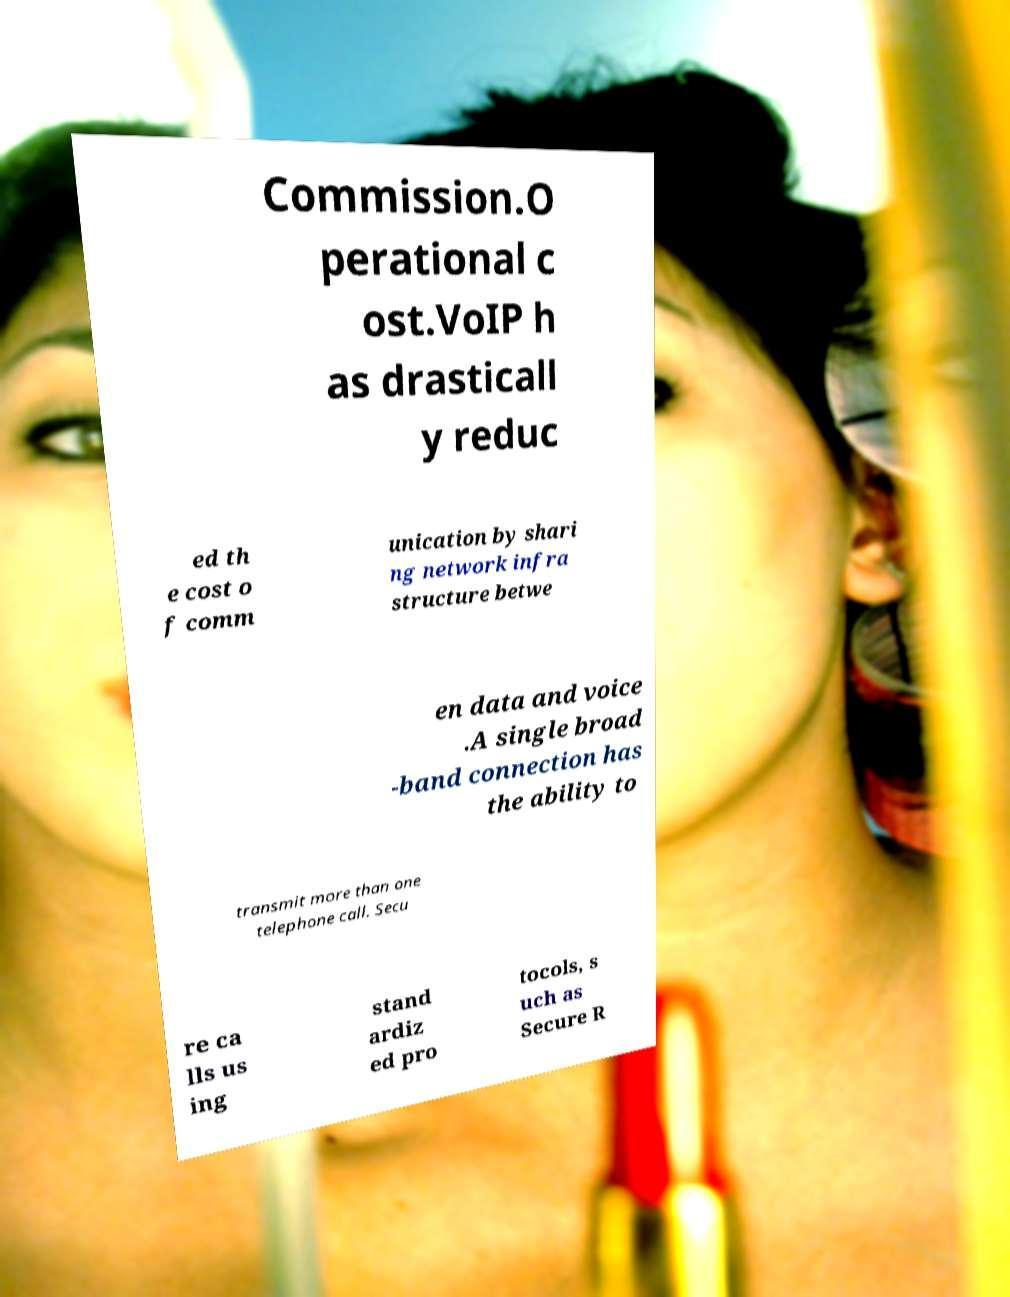For documentation purposes, I need the text within this image transcribed. Could you provide that? Commission.O perational c ost.VoIP h as drasticall y reduc ed th e cost o f comm unication by shari ng network infra structure betwe en data and voice .A single broad -band connection has the ability to transmit more than one telephone call. Secu re ca lls us ing stand ardiz ed pro tocols, s uch as Secure R 